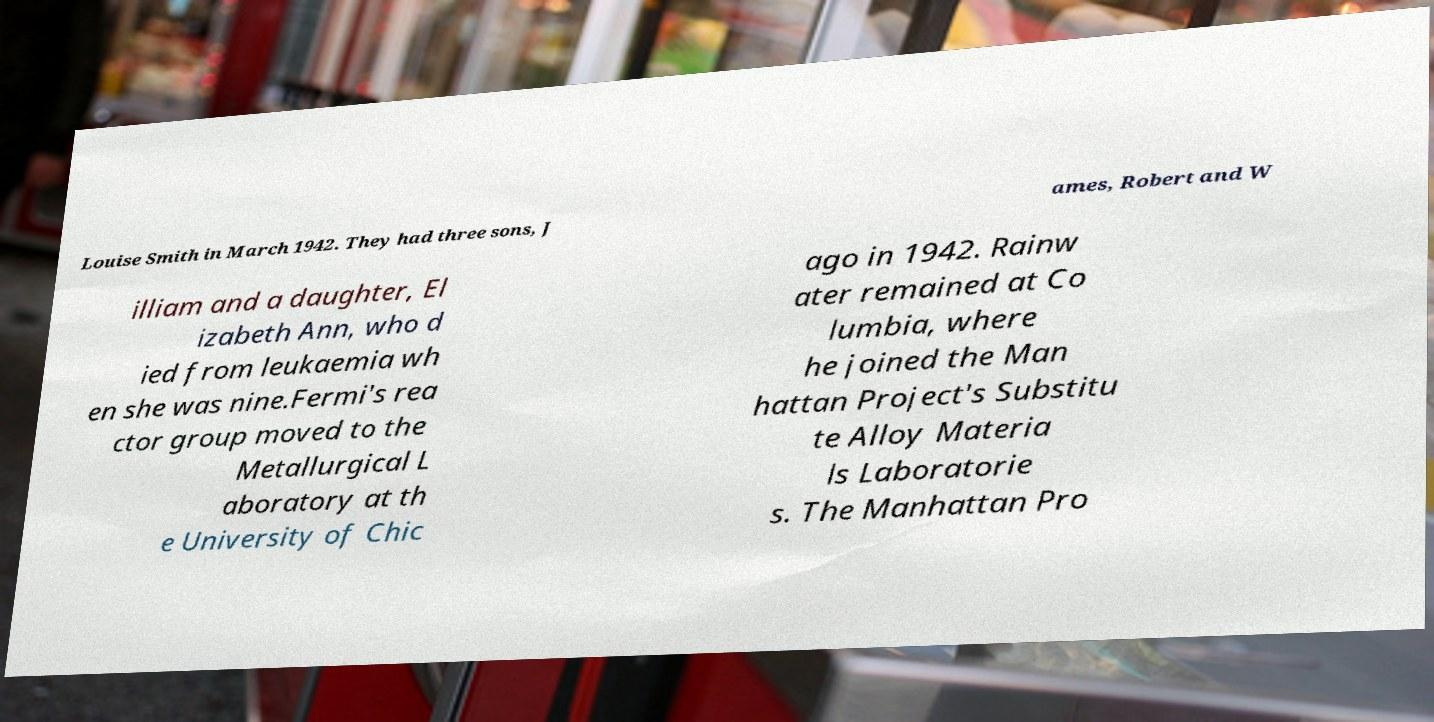What messages or text are displayed in this image? I need them in a readable, typed format. Louise Smith in March 1942. They had three sons, J ames, Robert and W illiam and a daughter, El izabeth Ann, who d ied from leukaemia wh en she was nine.Fermi's rea ctor group moved to the Metallurgical L aboratory at th e University of Chic ago in 1942. Rainw ater remained at Co lumbia, where he joined the Man hattan Project's Substitu te Alloy Materia ls Laboratorie s. The Manhattan Pro 